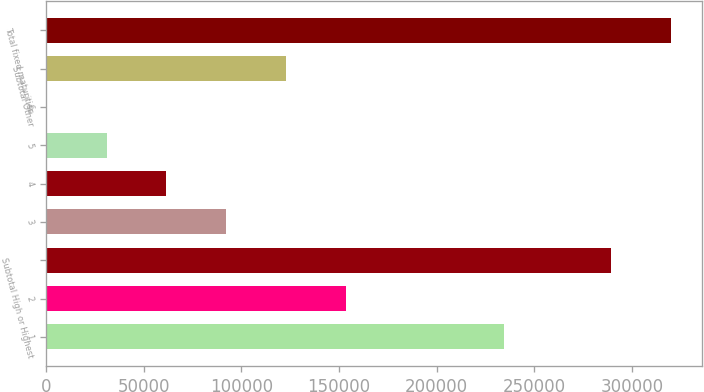Convert chart to OTSL. <chart><loc_0><loc_0><loc_500><loc_500><bar_chart><fcel>1<fcel>2<fcel>Subtotal High or Highest<fcel>3<fcel>4<fcel>5<fcel>6<fcel>Subtotal Other<fcel>Total fixed maturities<nl><fcel>234416<fcel>153792<fcel>289392<fcel>92372.5<fcel>61663<fcel>30953.5<fcel>244<fcel>123082<fcel>320102<nl></chart> 